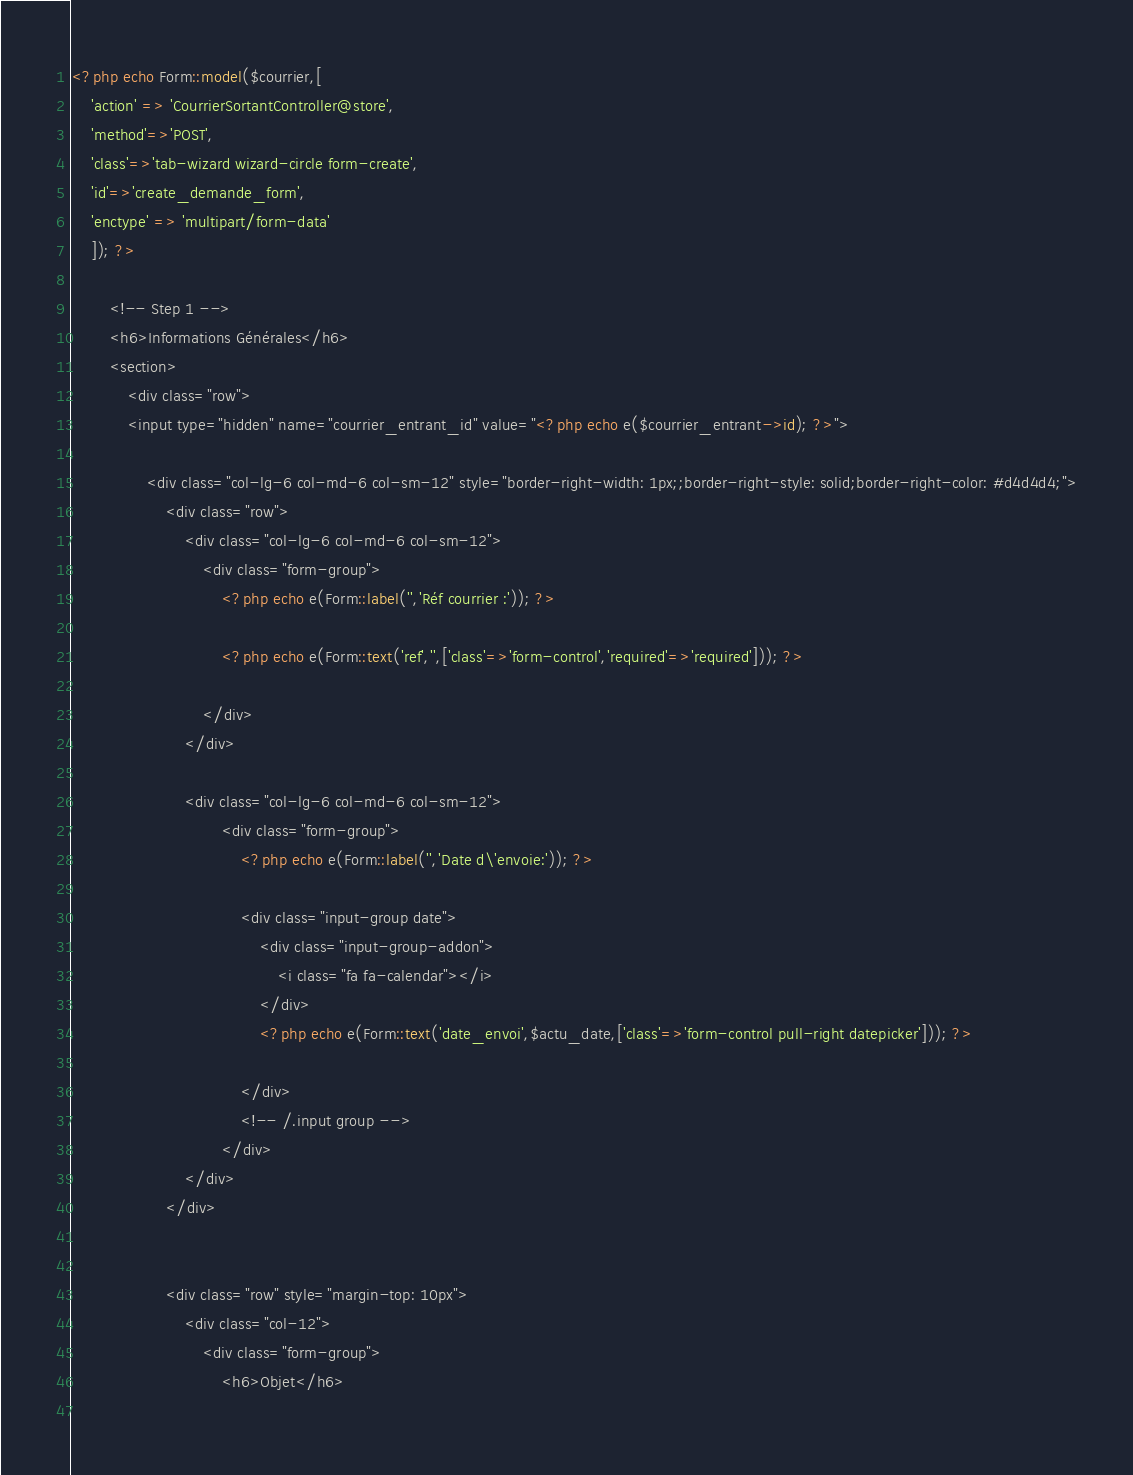Convert code to text. <code><loc_0><loc_0><loc_500><loc_500><_PHP_>
<?php echo Form::model($courrier,[
    'action' => 'CourrierSortantController@store',
    'method'=>'POST',
    'class'=>'tab-wizard wizard-circle form-create',
    'id'=>'create_demande_form',
    'enctype' => 'multipart/form-data'
    ]); ?>

        <!-- Step 1 -->
        <h6>Informations Générales</h6>
        <section>
            <div class="row">
            <input type="hidden" name="courrier_entrant_id" value="<?php echo e($courrier_entrant->id); ?>">
                
                <div class="col-lg-6 col-md-6 col-sm-12" style="border-right-width: 1px;;border-right-style: solid;border-right-color: #d4d4d4;">
                    <div class="row">
                        <div class="col-lg-6 col-md-6 col-sm-12">
                            <div class="form-group">
                                <?php echo e(Form::label('','Réf courrier :')); ?>

                                <?php echo e(Form::text('ref','',['class'=>'form-control','required'=>'required'])); ?>

                            </div>
                        </div>

                        <div class="col-lg-6 col-md-6 col-sm-12">                            
                                <div class="form-group">
                                    <?php echo e(Form::label('','Date d\'envoie:')); ?>

                                    <div class="input-group date">
                                        <div class="input-group-addon">
                                            <i class="fa fa-calendar"></i>
                                        </div>
                                        <?php echo e(Form::text('date_envoi',$actu_date,['class'=>'form-control pull-right datepicker'])); ?>

                                    </div>
                                    <!-- /.input group -->
                                </div>
                        </div>
                    </div>
 

                    <div class="row" style="margin-top: 10px">
                        <div class="col-12">
                            <div class="form-group">
                                <h6>Objet</h6>
                           </code> 